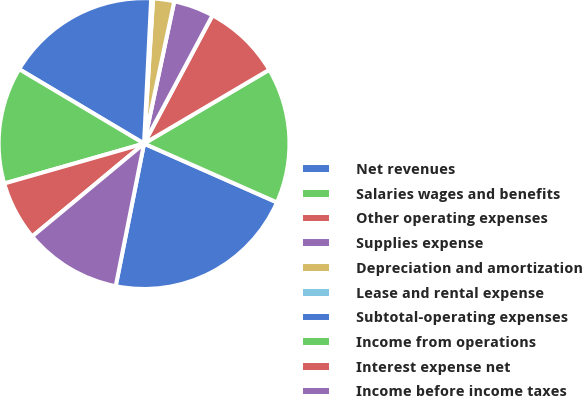<chart> <loc_0><loc_0><loc_500><loc_500><pie_chart><fcel>Net revenues<fcel>Salaries wages and benefits<fcel>Other operating expenses<fcel>Supplies expense<fcel>Depreciation and amortization<fcel>Lease and rental expense<fcel>Subtotal-operating expenses<fcel>Income from operations<fcel>Interest expense net<fcel>Income before income taxes<nl><fcel>21.49%<fcel>15.11%<fcel>8.72%<fcel>4.47%<fcel>2.34%<fcel>0.21%<fcel>17.23%<fcel>12.98%<fcel>6.6%<fcel>10.85%<nl></chart> 